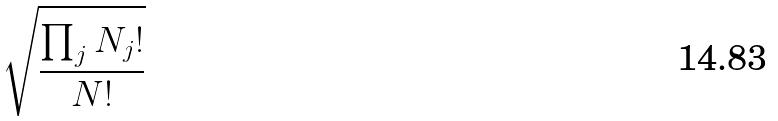Convert formula to latex. <formula><loc_0><loc_0><loc_500><loc_500>\sqrt { \frac { \prod _ { j } N _ { j } ! } { N ! } }</formula> 